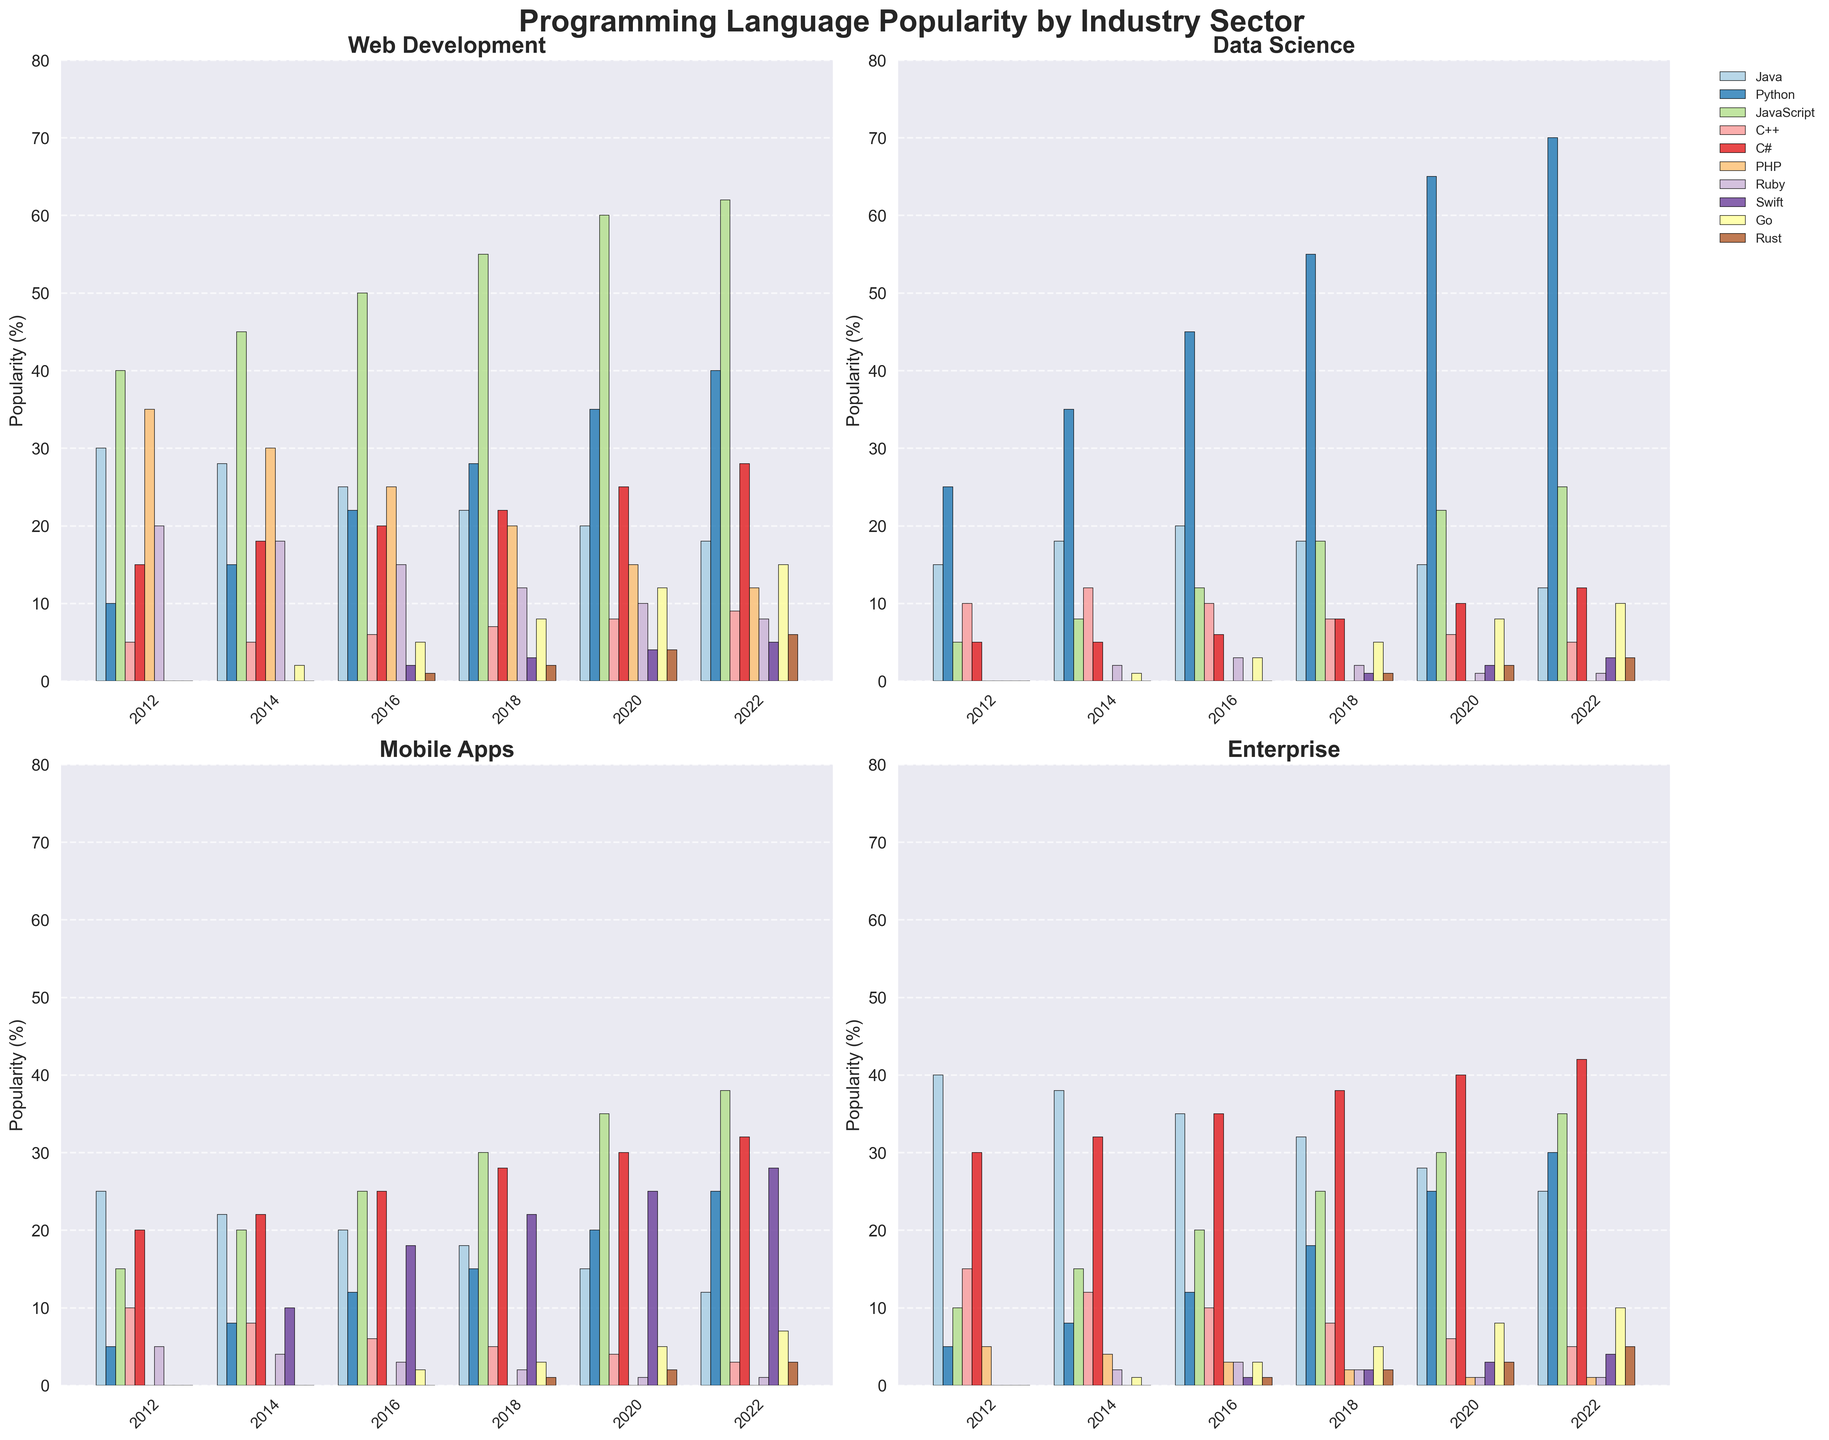What's the most popular language in web development in 2022? To find the most popular language in web development in 2022, observe the height of the bars for 2022 in the "Web Development" subplot. The bar labeled "JavaScript" is the highest.
Answer: JavaScript Which sector saw the largest increase in Python popularity between 2012 and 2022? Compare the bar heights for Python in 2012 and 2022 across all sectors. The "Data Science" sector shows the largest increase, going from 25% in 2012 to 70% in 2022.
Answer: Data Science In 2020, is Java more popular in enterprise or mobile apps? Look at the bar heights for Java in 2020 in the "Enterprise" and "Mobile Apps" subplots. The bar is higher in "Enterprise."
Answer: Enterprise Which language had the highest growth in popularity in mobile apps from 2012 to 2022? Compare the bar heights for each language in 2012 and 2022 in the "Mobile Apps" subplot. Swift shows the highest growth, going from 0% in 2012 to 28% in 2022.
Answer: Swift How much did the popularity of JavaScript increase in web development from 2012 to 2022? Find the bar heights for JavaScript in 2012 and 2022 in the "Web Development" subplot. The height increased from 40% in 2012 to 62% in 2022, an increase of 22%.
Answer: 22% Which language had the lowest popularity in data science in 2022? Look at the bar heights for all languages in the "Data Science" subplot for 2022. The bar for PHP is the lowest at 0%.
Answer: PHP How did the popularity of C# in enterprise change from 2012 to 2022? Compare the bar heights for C# in the "Enterprise" subplot for 2012 and 2022. The height increased from 30% in 2012 to 42% in 2022, showing an increase of 12%.
Answer: Increased by 12% In 2016, which language was more popular in web development: C++ or Go? In the "Web Development" subplot for 2016, compare the heights of the bars for C++ and Go. The bar for C++ is higher than that of Go.
Answer: C++ For the web development sector, what is the average popularity of Ruby across all given years? Add the popularity percentages of Ruby in web development for all listed years: (2012: 20 + 2014: 18 + 2016: 15 + 2018: 12 + 2020: 10 + 2022: 8), then divide by the number of years (6). The total is 83/6 ≈ 13.83%.
Answer: 13.83% Compare the popularity of Go in mobile apps and web development in 2022. Which sector has a higher percentage? Look at the bar heights for Go in both "Mobile Apps" and "Web Development" subplots for 2022. The height in "Web Development" is higher than in "Mobile Apps."
Answer: Web Development 